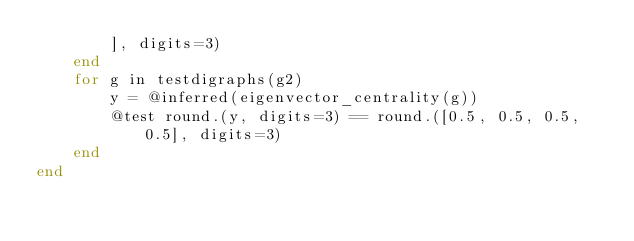Convert code to text. <code><loc_0><loc_0><loc_500><loc_500><_Julia_>        ], digits=3)
    end
    for g in testdigraphs(g2)
        y = @inferred(eigenvector_centrality(g))
        @test round.(y, digits=3) == round.([0.5, 0.5, 0.5, 0.5], digits=3)
    end
end
</code> 